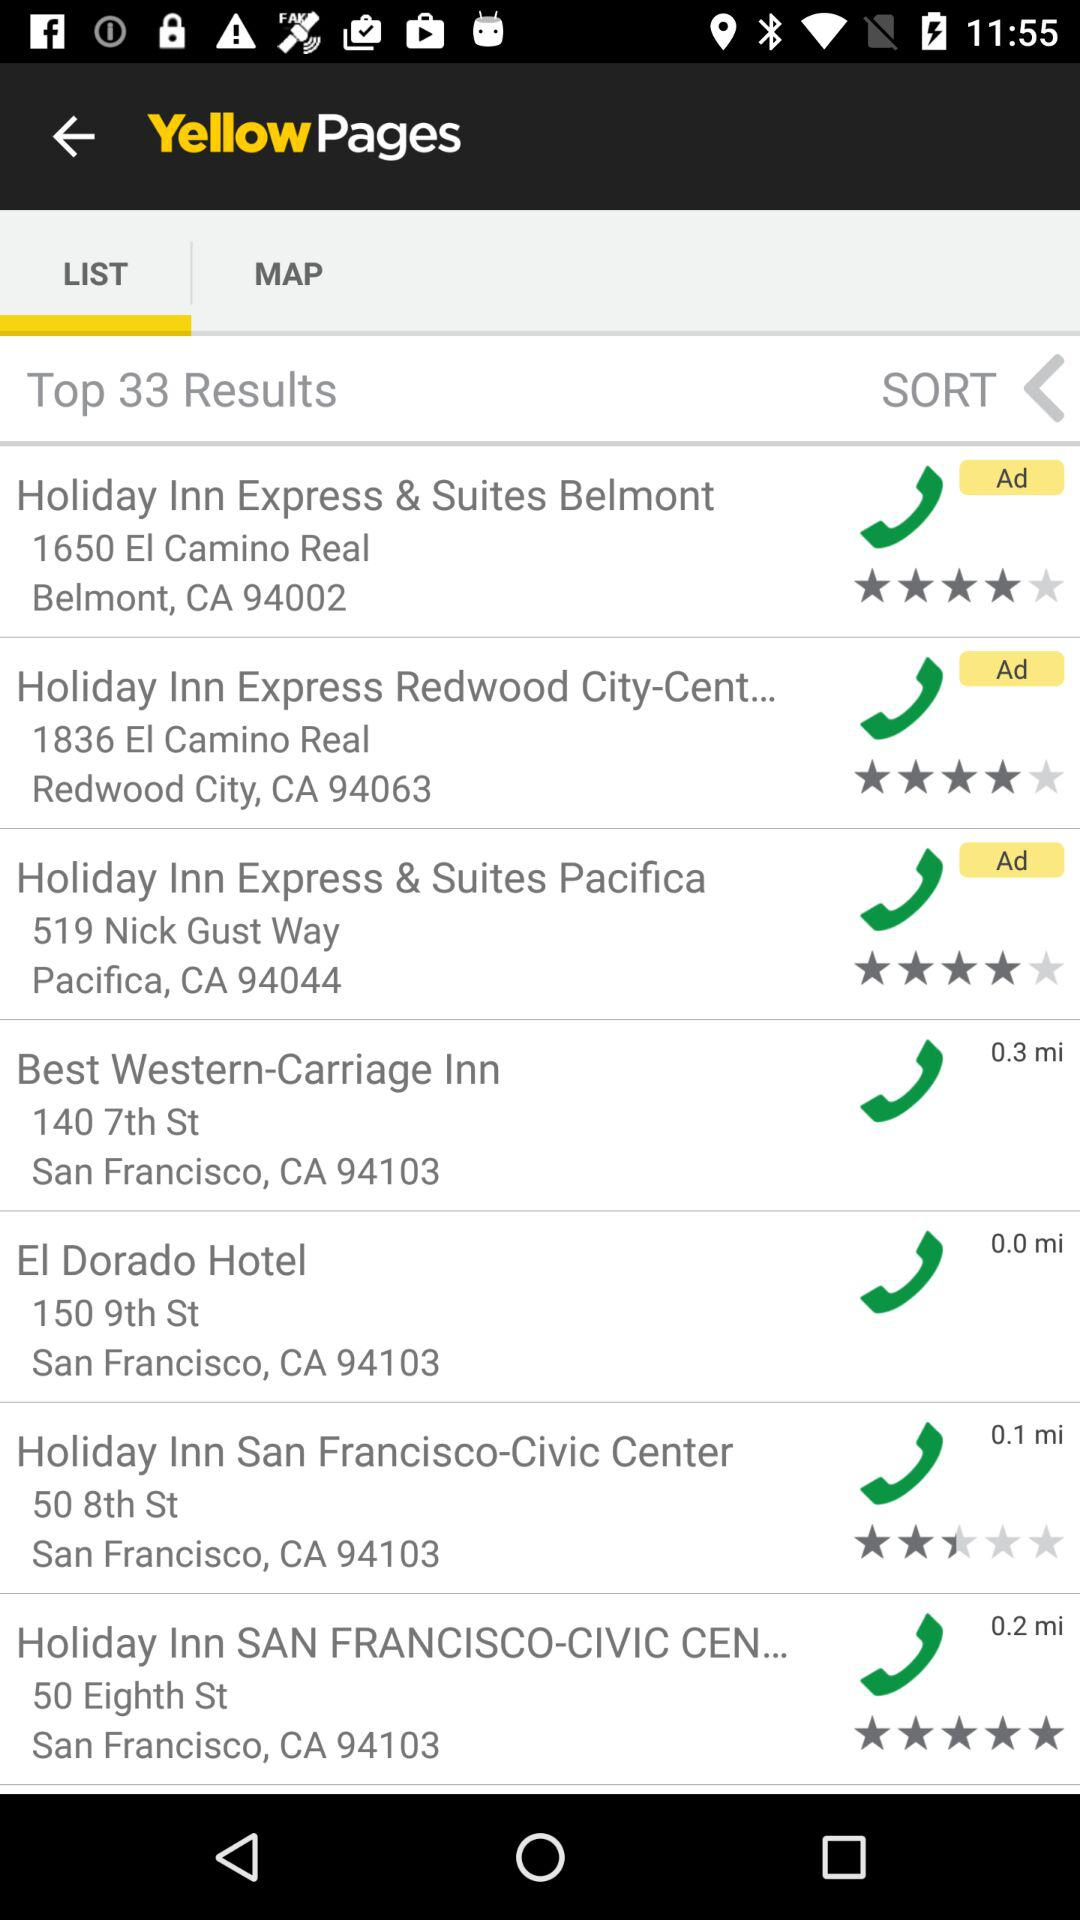What is the address of the "Best Western-Carriage Inn"? The address is 140 7th St, San Francisco, CA 94103. 